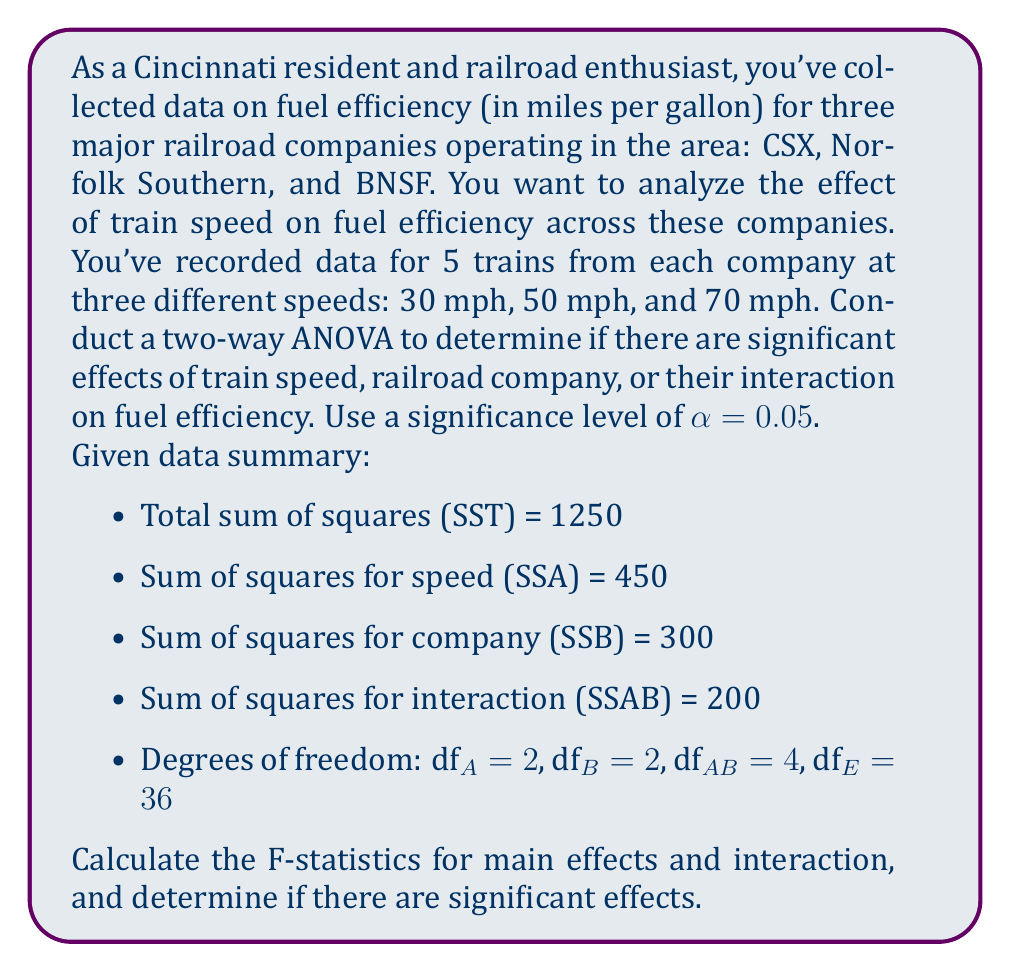Can you answer this question? Let's approach this problem step-by-step:

1) First, we need to calculate the sum of squares for error (SSE):
   $$SSE = SST - SSA - SSB - SSAB = 1250 - 450 - 300 - 200 = 300$$

2) Now, we can create an ANOVA table:

   Source      | SS   | df | MS    | F
   ------------|------|----|-------|----
   Speed (A)   | 450  | 2  | 225   | ?
   Company (B) | 300  | 2  | 150   | ?
   A x B       | 200  | 4  | 50    | ?
   Error       | 300  | 36 | 8.333 |
   Total       | 1250 | 44 |       |

3) Calculate Mean Squares (MS) for each source:
   $$MS_A = \frac{SSA}{df_A} = \frac{450}{2} = 225$$
   $$MS_B = \frac{SSB}{df_B} = \frac{300}{2} = 150$$
   $$MS_{AB} = \frac{SSAB}{df_{AB}} = \frac{200}{4} = 50$$
   $$MS_E = \frac{SSE}{df_E} = \frac{300}{36} = 8.333$$

4) Calculate F-statistics:
   $$F_A = \frac{MS_A}{MS_E} = \frac{225}{8.333} = 27$$
   $$F_B = \frac{MS_B}{MS_E} = \frac{150}{8.333} = 18$$
   $$F_{AB} = \frac{MS_{AB}}{MS_E} = \frac{50}{8.333} = 6$$

5) Determine critical F-values:
   For α = 0.05:
   F(2,36) ≈ 3.26 for main effects
   F(4,36) ≈ 2.63 for interaction

6) Compare F-statistics to critical values:
   - For speed: 27 > 3.26, so significant effect
   - For company: 18 > 3.26, so significant effect
   - For interaction: 6 > 2.63, so significant interaction
Answer: There are significant effects of train speed (F = 27, p < 0.05), railroad company (F = 18, p < 0.05), and their interaction (F = 6, p < 0.05) on fuel efficiency. 